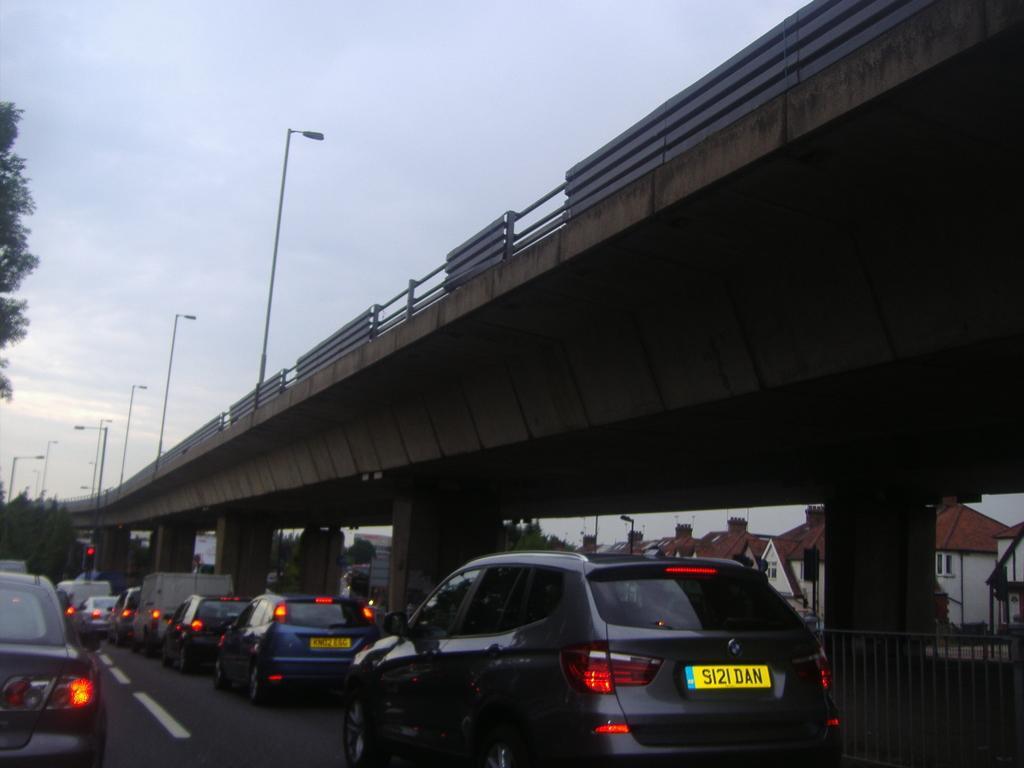Describe this image in one or two sentences. In this picture we see many vehicles on the road under a flyover bridge with lamp posts. The sky is gloomy. 